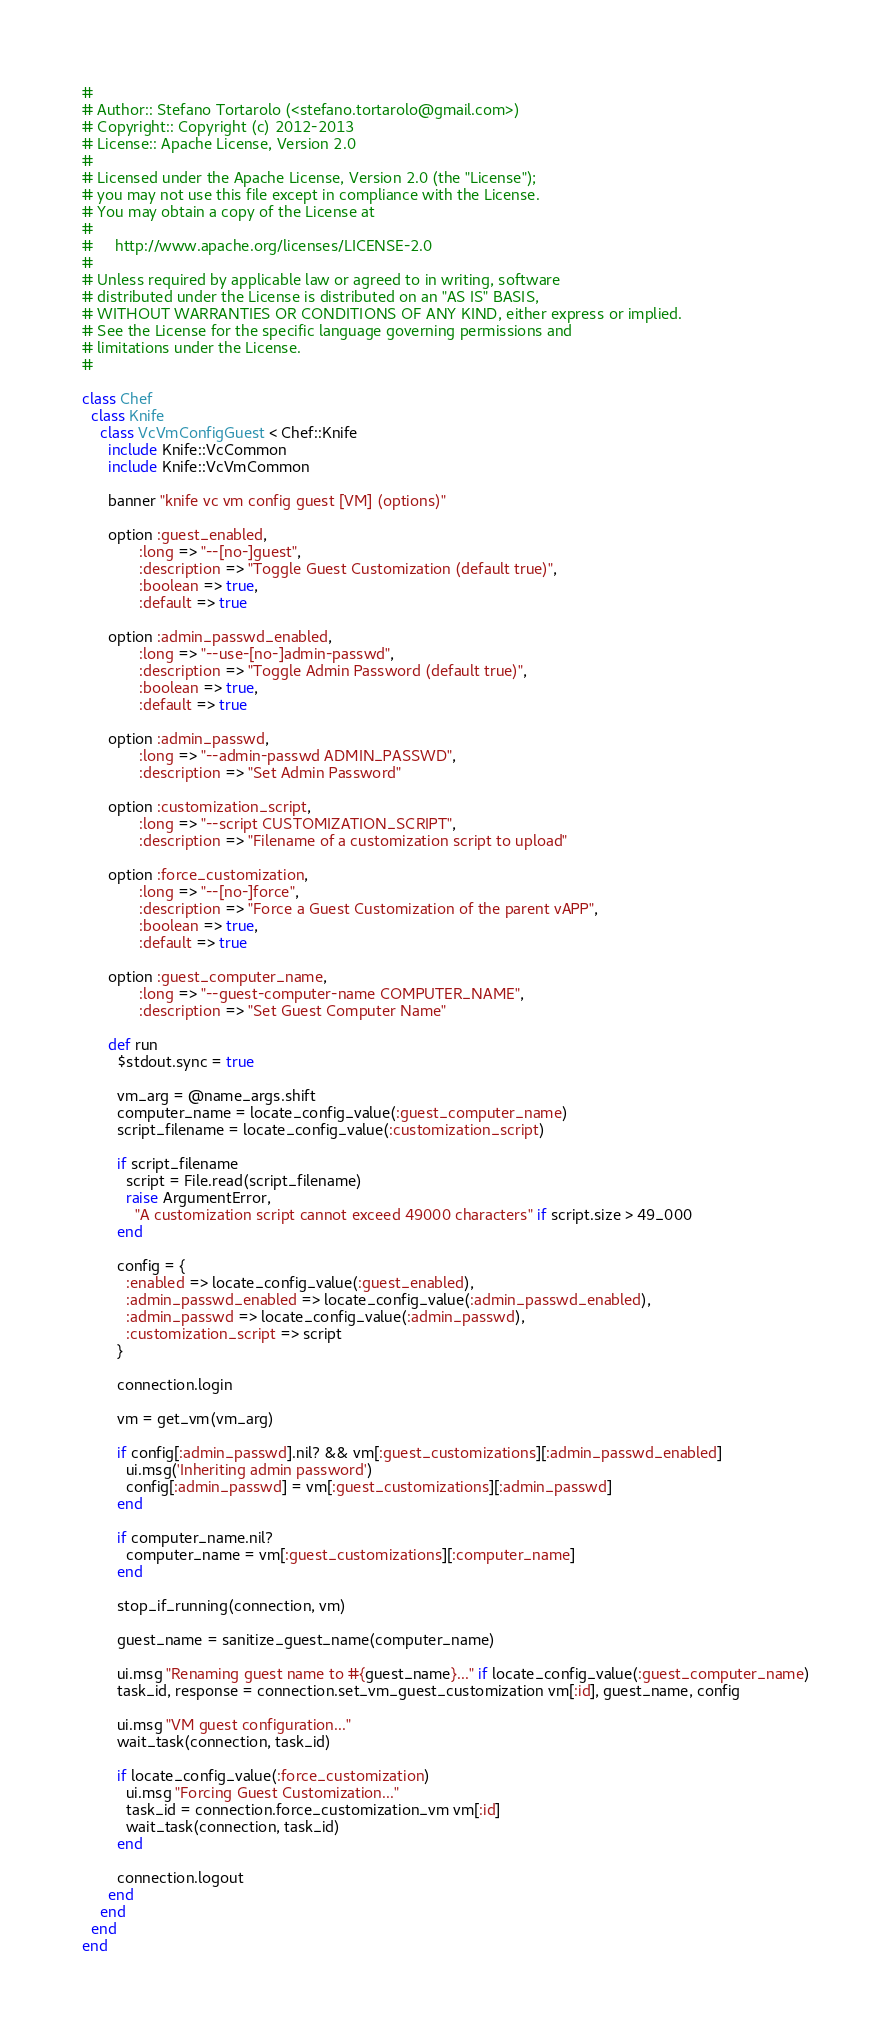Convert code to text. <code><loc_0><loc_0><loc_500><loc_500><_Ruby_>#
# Author:: Stefano Tortarolo (<stefano.tortarolo@gmail.com>)
# Copyright:: Copyright (c) 2012-2013
# License:: Apache License, Version 2.0
#
# Licensed under the Apache License, Version 2.0 (the "License");
# you may not use this file except in compliance with the License.
# You may obtain a copy of the License at
#
#     http://www.apache.org/licenses/LICENSE-2.0
#
# Unless required by applicable law or agreed to in writing, software
# distributed under the License is distributed on an "AS IS" BASIS,
# WITHOUT WARRANTIES OR CONDITIONS OF ANY KIND, either express or implied.
# See the License for the specific language governing permissions and
# limitations under the License.
#

class Chef
  class Knife
    class VcVmConfigGuest < Chef::Knife
      include Knife::VcCommon
      include Knife::VcVmCommon

      banner "knife vc vm config guest [VM] (options)"

      option :guest_enabled,
             :long => "--[no-]guest",
             :description => "Toggle Guest Customization (default true)",
             :boolean => true,
             :default => true

      option :admin_passwd_enabled,
             :long => "--use-[no-]admin-passwd",
             :description => "Toggle Admin Password (default true)",
             :boolean => true,
             :default => true

      option :admin_passwd,
             :long => "--admin-passwd ADMIN_PASSWD",
             :description => "Set Admin Password"

      option :customization_script,
             :long => "--script CUSTOMIZATION_SCRIPT",
             :description => "Filename of a customization script to upload"

      option :force_customization,
             :long => "--[no-]force",
             :description => "Force a Guest Customization of the parent vAPP",
             :boolean => true,
             :default => true

      option :guest_computer_name,
             :long => "--guest-computer-name COMPUTER_NAME",
             :description => "Set Guest Computer Name"

      def run
        $stdout.sync = true

        vm_arg = @name_args.shift
        computer_name = locate_config_value(:guest_computer_name)
        script_filename = locate_config_value(:customization_script)

        if script_filename
          script = File.read(script_filename)
          raise ArgumentError,
            "A customization script cannot exceed 49000 characters" if script.size > 49_000
        end

        config = {
          :enabled => locate_config_value(:guest_enabled),
          :admin_passwd_enabled => locate_config_value(:admin_passwd_enabled),
          :admin_passwd => locate_config_value(:admin_passwd),
          :customization_script => script
        }

        connection.login

        vm = get_vm(vm_arg)

        if config[:admin_passwd].nil? && vm[:guest_customizations][:admin_passwd_enabled]
          ui.msg('Inheriting admin password')
          config[:admin_passwd] = vm[:guest_customizations][:admin_passwd]
        end

        if computer_name.nil?
          computer_name = vm[:guest_customizations][:computer_name]
        end

        stop_if_running(connection, vm)

        guest_name = sanitize_guest_name(computer_name)

        ui.msg "Renaming guest name to #{guest_name}..." if locate_config_value(:guest_computer_name)
        task_id, response = connection.set_vm_guest_customization vm[:id], guest_name, config

        ui.msg "VM guest configuration..."
        wait_task(connection, task_id)

        if locate_config_value(:force_customization)
          ui.msg "Forcing Guest Customization..."
          task_id = connection.force_customization_vm vm[:id]
          wait_task(connection, task_id)
        end

        connection.logout
      end
    end
  end
end
</code> 